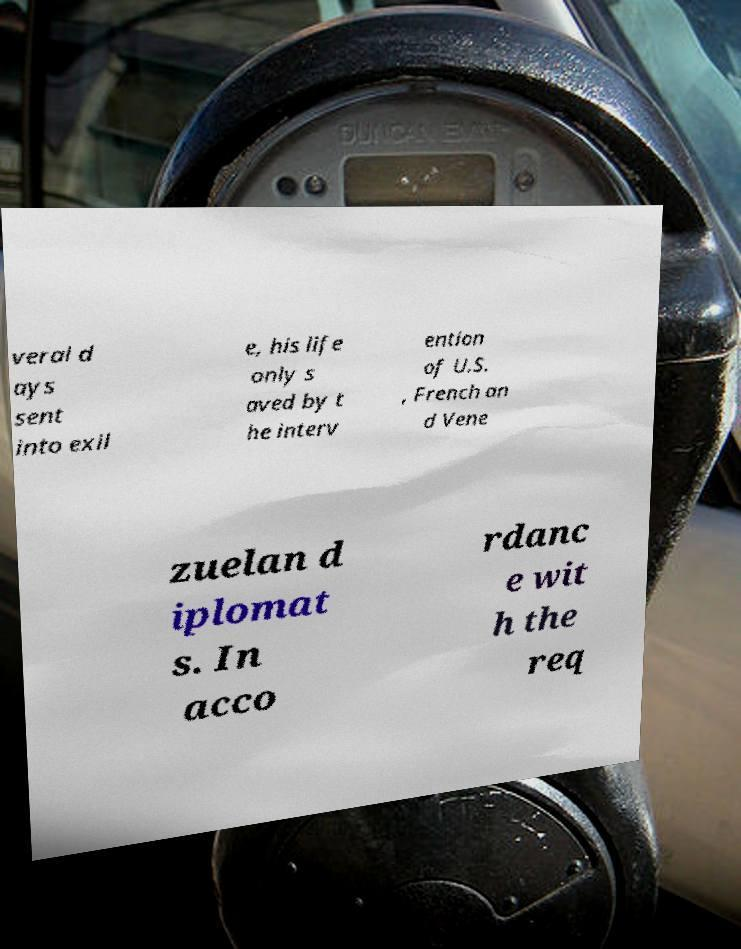Could you extract and type out the text from this image? veral d ays sent into exil e, his life only s aved by t he interv ention of U.S. , French an d Vene zuelan d iplomat s. In acco rdanc e wit h the req 